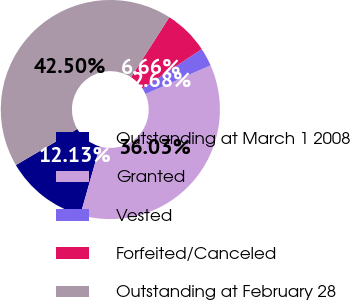Convert chart. <chart><loc_0><loc_0><loc_500><loc_500><pie_chart><fcel>Outstanding at March 1 2008<fcel>Granted<fcel>Vested<fcel>Forfeited/Canceled<fcel>Outstanding at February 28<nl><fcel>12.13%<fcel>36.03%<fcel>2.68%<fcel>6.66%<fcel>42.5%<nl></chart> 